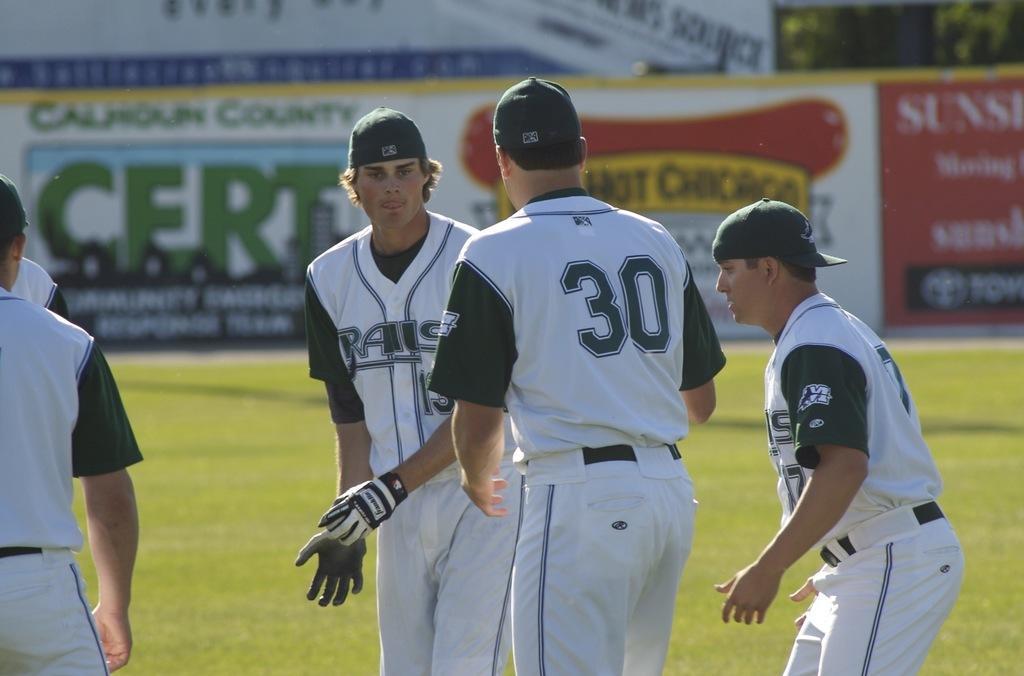What is the nearest player's number?
Keep it short and to the point. 30. How many players are wearing gloves?
Make the answer very short. Answering does not require reading text in the image. 